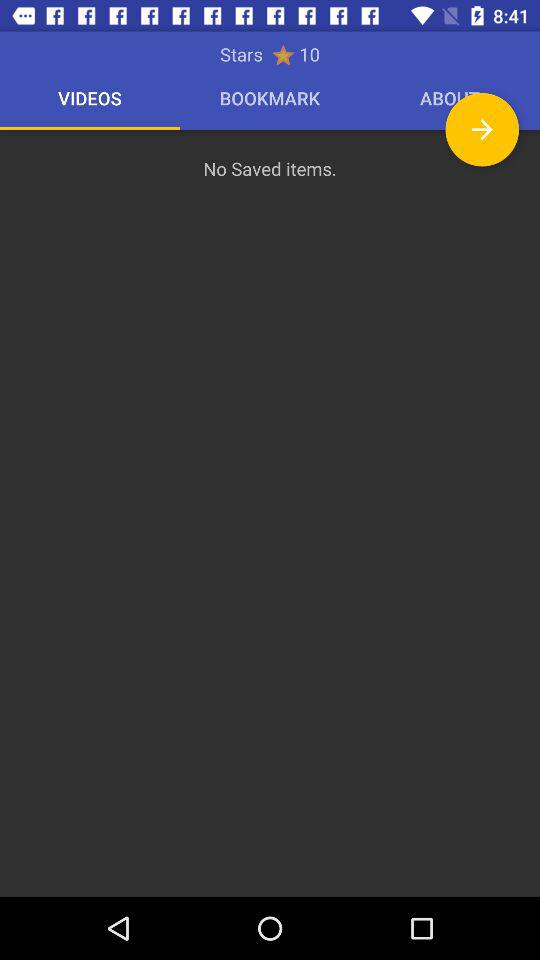Which videos are bookmarked?
When the provided information is insufficient, respond with <no answer>. <no answer> 